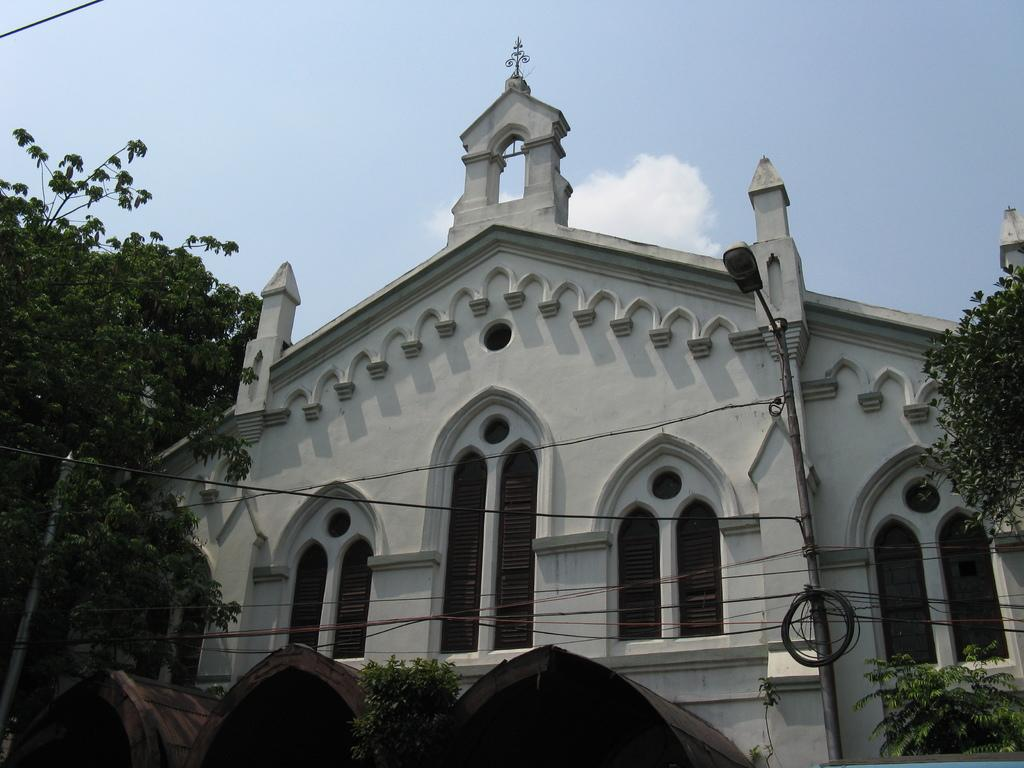What type of structure is present in the image? There is a building in the image. What can be seen near the building? There is a street light in the image. What architectural feature can be observed on the building? There are windows visible in the image. What type of vegetation is present in the image? There are trees in the image. What else is present in the image besides the building and trees? Cables are present in the image. What is visible in the sky in the image? Clouds are visible in the sky. What type of punishment is being administered to the trees in the image? There is no punishment being administered to the trees in the image; they are simply standing in the background. 